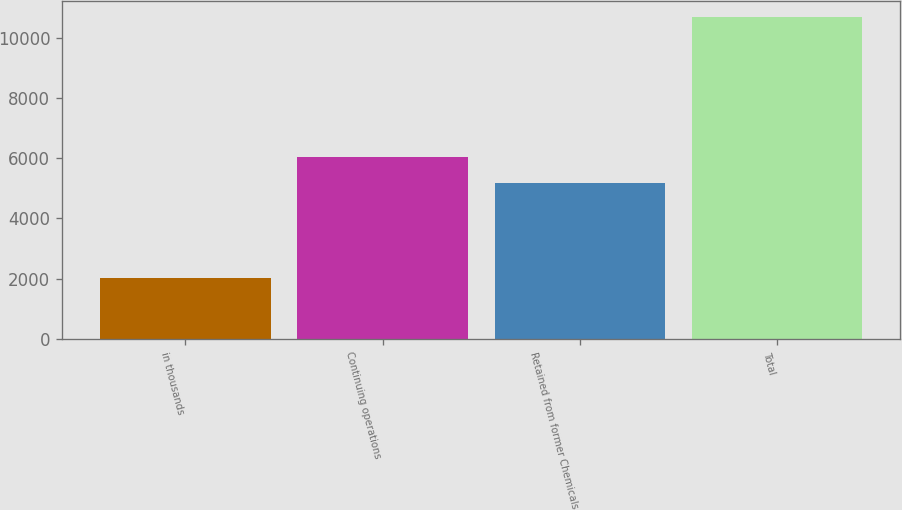Convert chart to OTSL. <chart><loc_0><loc_0><loc_500><loc_500><bar_chart><fcel>in thousands<fcel>Continuing operations<fcel>Retained from former Chemicals<fcel>Total<nl><fcel>2013<fcel>6045<fcel>5178<fcel>10683<nl></chart> 